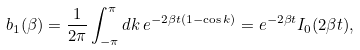<formula> <loc_0><loc_0><loc_500><loc_500>b _ { 1 } ( \beta ) = \frac { 1 } { 2 \pi } \int _ { - \pi } ^ { \pi } d k \, e ^ { - 2 \beta t ( 1 - \cos k ) } = e ^ { - 2 \beta t } I _ { 0 } ( 2 \beta t ) ,</formula> 